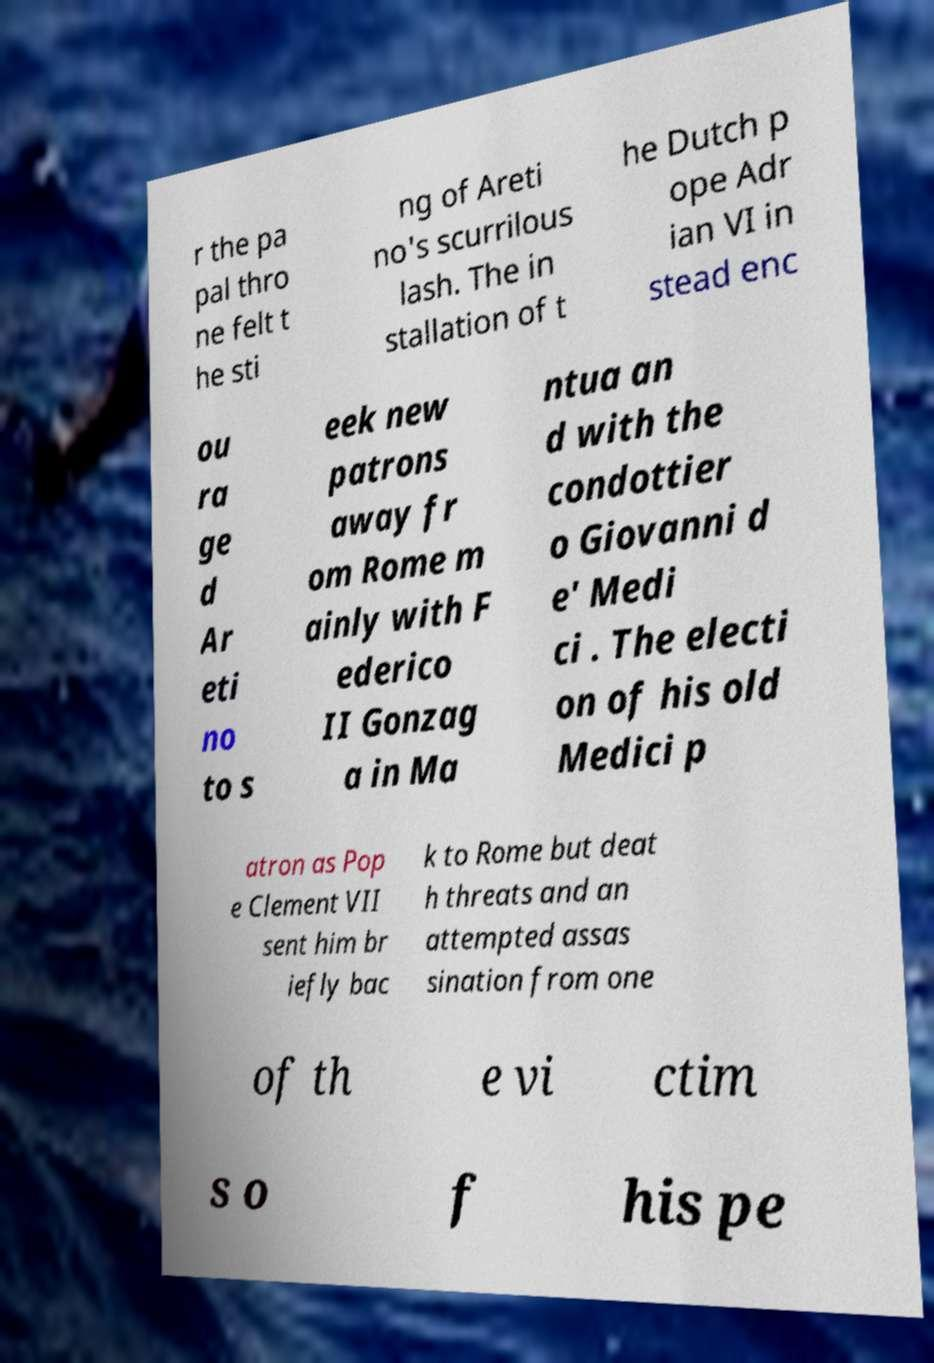Could you extract and type out the text from this image? r the pa pal thro ne felt t he sti ng of Areti no's scurrilous lash. The in stallation of t he Dutch p ope Adr ian VI in stead enc ou ra ge d Ar eti no to s eek new patrons away fr om Rome m ainly with F ederico II Gonzag a in Ma ntua an d with the condottier o Giovanni d e' Medi ci . The electi on of his old Medici p atron as Pop e Clement VII sent him br iefly bac k to Rome but deat h threats and an attempted assas sination from one of th e vi ctim s o f his pe 